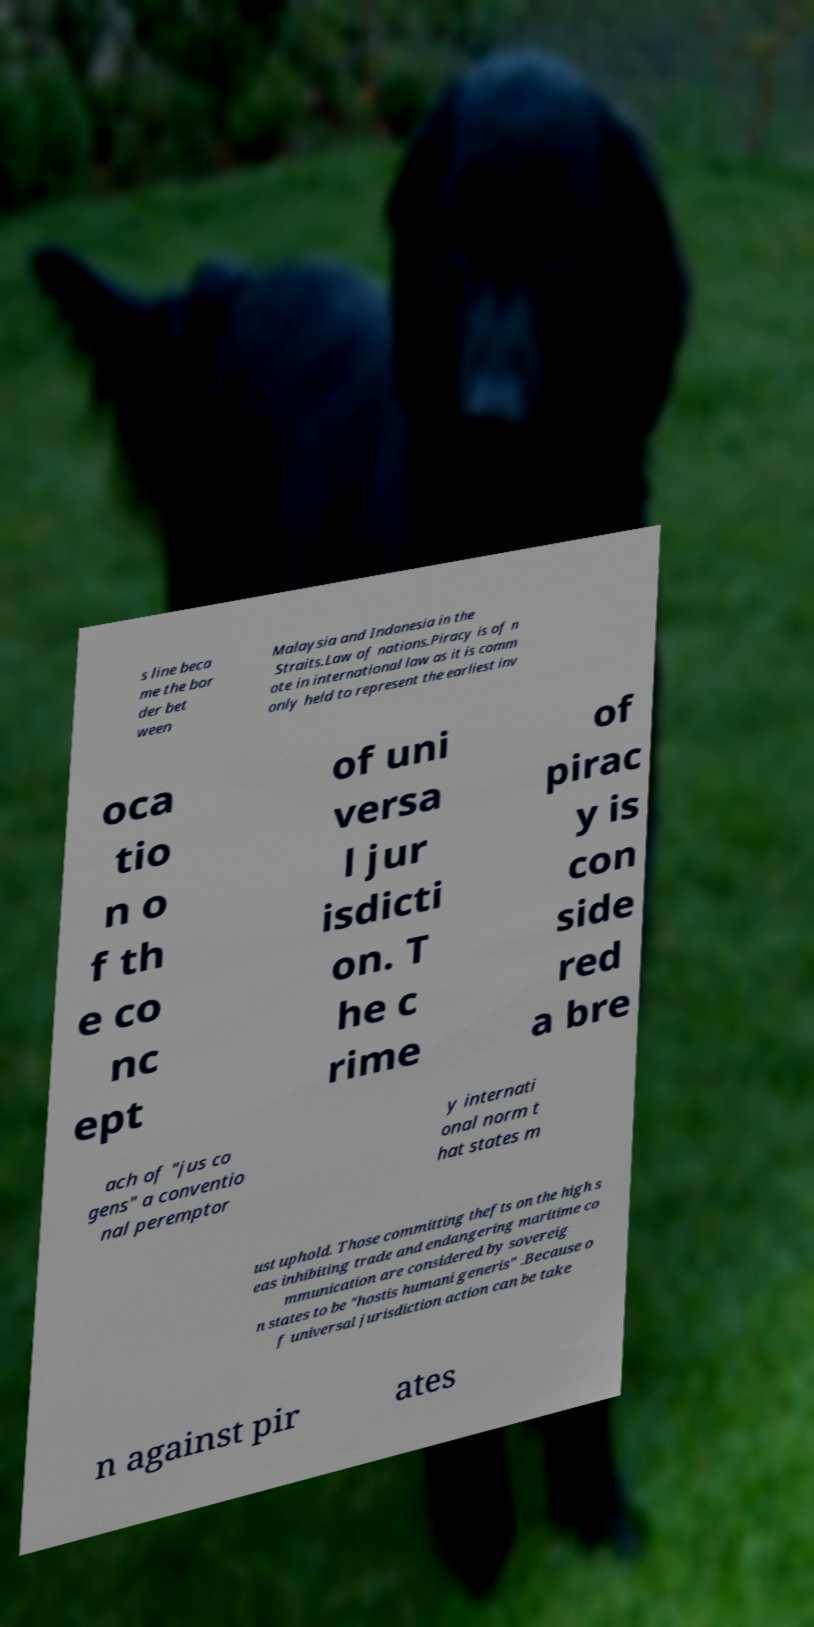Could you extract and type out the text from this image? s line beca me the bor der bet ween Malaysia and Indonesia in the Straits.Law of nations.Piracy is of n ote in international law as it is comm only held to represent the earliest inv oca tio n o f th e co nc ept of uni versa l jur isdicti on. T he c rime of pirac y is con side red a bre ach of "jus co gens" a conventio nal peremptor y internati onal norm t hat states m ust uphold. Those committing thefts on the high s eas inhibiting trade and endangering maritime co mmunication are considered by sovereig n states to be "hostis humani generis" .Because o f universal jurisdiction action can be take n against pir ates 